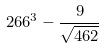Convert formula to latex. <formula><loc_0><loc_0><loc_500><loc_500>2 6 6 ^ { 3 } - \frac { 9 } { \sqrt { 4 6 2 } }</formula> 